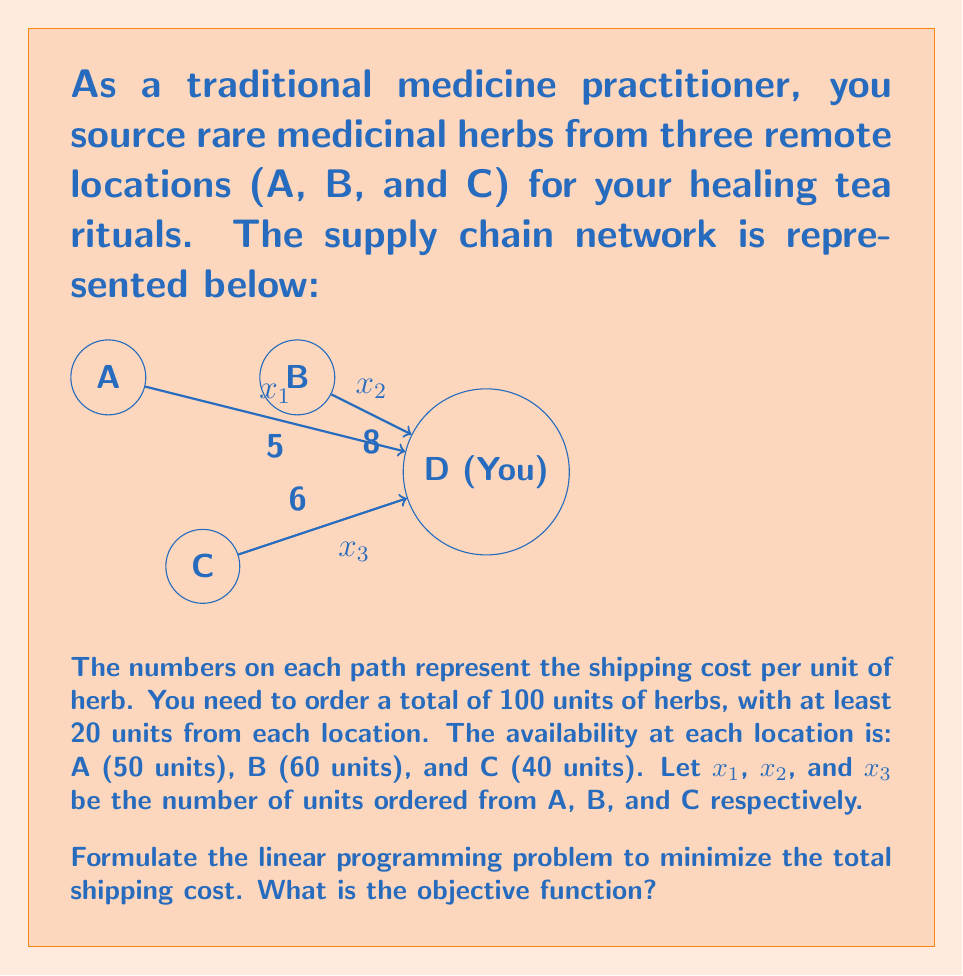Give your solution to this math problem. To formulate the linear programming problem, we need to define the objective function and constraints based on the given information.

1. Objective Function:
   The goal is to minimize the total shipping cost. The cost per unit for each path is given, and we multiply it by the number of units shipped from each location.
   
   Minimize: $$ Z = 5x_1 + 8x_2 + 6x_3 $$

2. Constraints:
   a) Total order constraint:
      $$ x_1 + x_2 + x_3 = 100 $$
   
   b) Minimum order constraints:
      $$ x_1 \geq 20 $$
      $$ x_2 \geq 20 $$
      $$ x_3 \geq 20 $$
   
   c) Availability constraints:
      $$ x_1 \leq 50 $$
      $$ x_2 \leq 60 $$
      $$ x_3 \leq 40 $$
   
   d) Non-negativity constraints:
      $$ x_1, x_2, x_3 \geq 0 $$

The objective function represents the total shipping cost, which is the sum of the costs from each location. This is what we aim to minimize in this linear programming problem.
Answer: $Z = 5x_1 + 8x_2 + 6x_3$ 